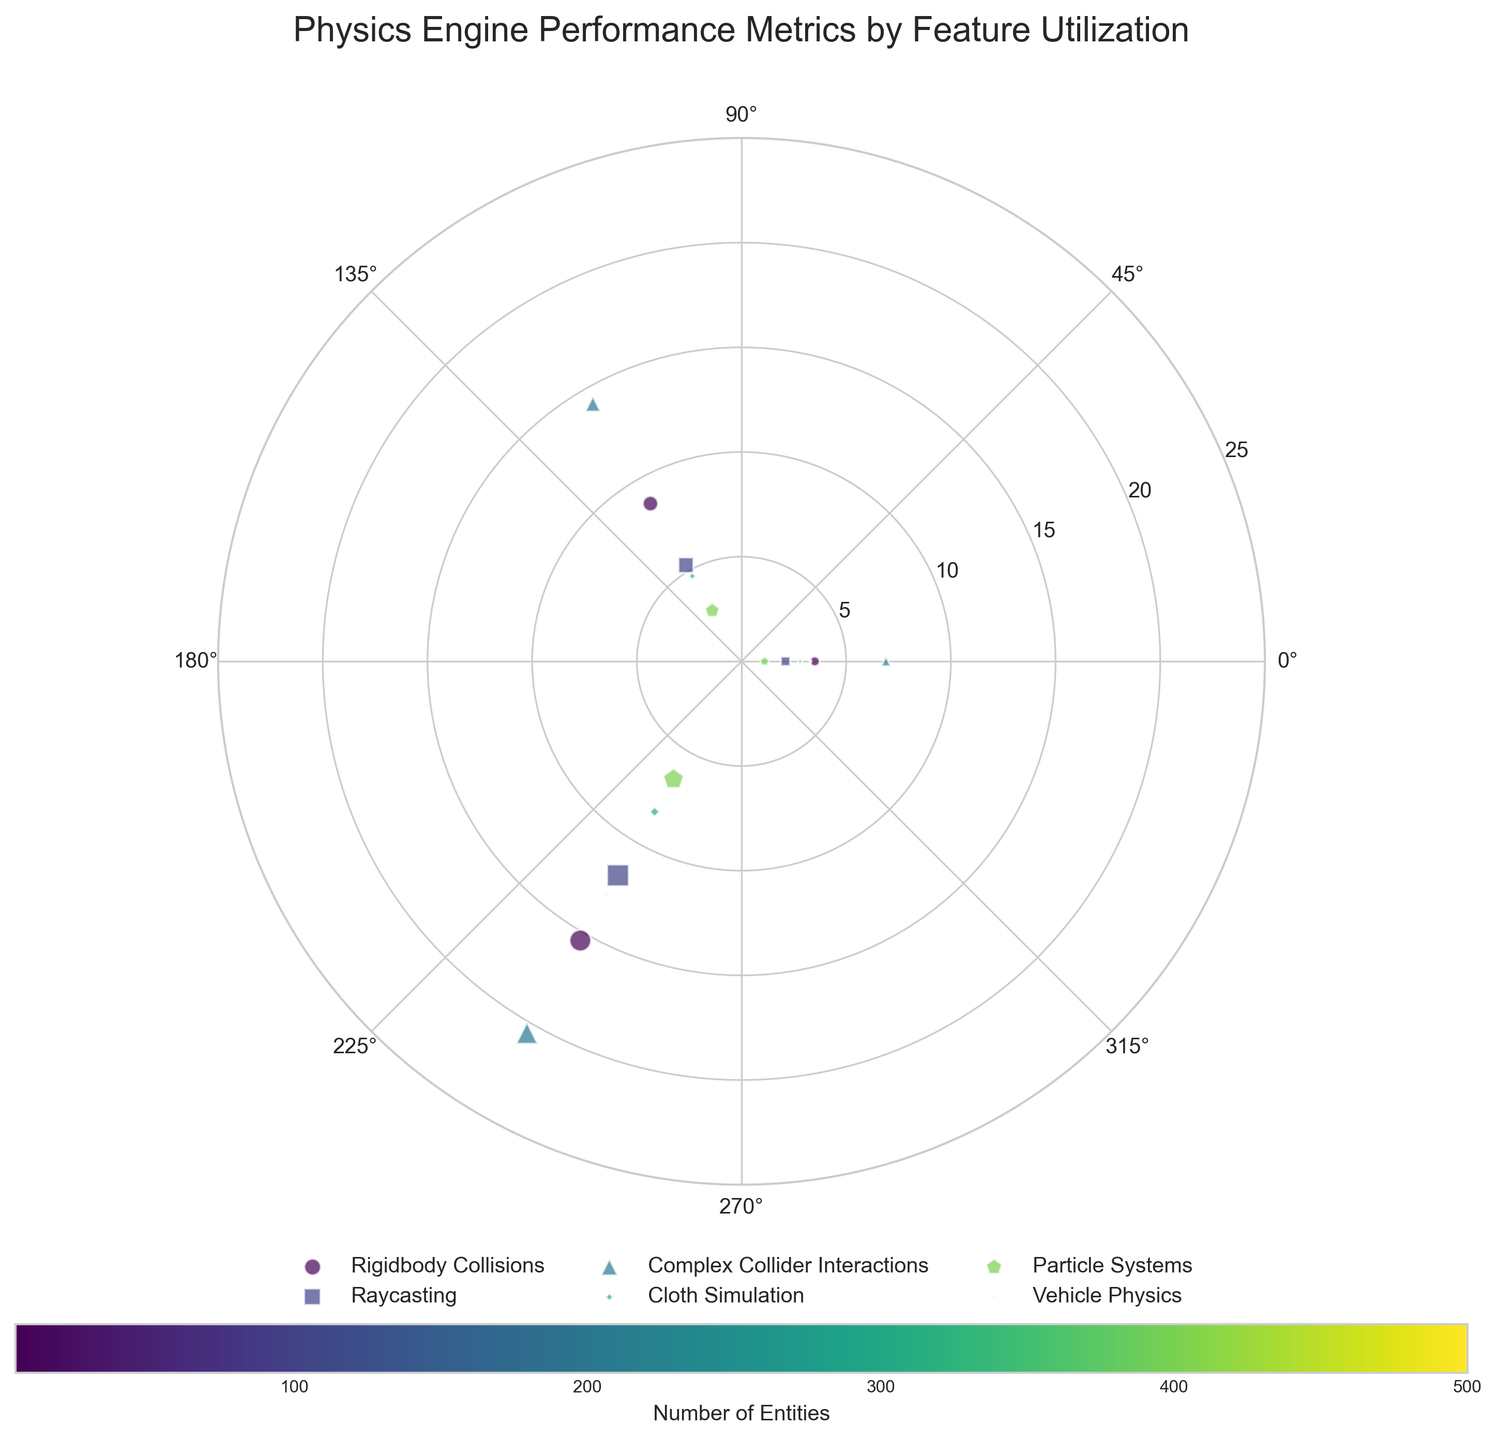What's the title of the figure? The title is typically located at the top of the figure. In this case, it reads "Physics Engine Performance Metrics by Feature Utilization".
Answer: Physics Engine Performance Metrics by Feature Utilization How many unique features are there in the plot? The figure legend shows different colored markers representing unique features. By counting these unique labels, we find there are 6 features: "Rigidbody Collisions", "Raycasting", "Complex Collider Interactions", "Cloth Simulation", "Particle Systems", and "Vehicle Physics".
Answer: 6 Which feature has the highest performance metric for the smallest entity count? Locate the smallest entity counts on the radial axis (innermost points), then check which has the highest radial distance (performance metric). For entities count of 5, "Vehicle Physics" has a performance metric of 3.3, which is the highest.
Answer: Vehicle Physics What's the average performance metric for "Raycasting" across all entity counts? Identify the performance metrics for "Raycasting" (2.1, 5.3, 11.8). Calculate the average: (2.1 + 5.3 + 11.8) / 3 = 6.4.
Answer: 6.4 Compare "Rigidbody Collisions" and "Cloth Simulation" features. Which one has a higher performance metric at the highest entity count? For "Rigidbody Collisions" at 500 entities, the performance metric is 15.4. For "Cloth Simulation" at 50 entities (which is the highest for this feature), the performance metric is 8.3. Compare these values: 15.4 > 8.3.
Answer: Rigidbody Collisions Which feature shows the highest performance metric regardless of entities count? Scan through all the radial distances for each feature. The highest value is 20.5 for "Complex Collider Interactions" when the entity count is 500.
Answer: Complex Collider Interactions For "Particle Systems", what is the difference in performance metric between 250 and 500 entities? Identify the performance metrics for 250 entities (2.8) and 500 entities (6.5). Compute the difference: 6.5 - 2.8 = 3.7.
Answer: 3.7 How are the entity counts visually represented in the plot? The size of the plotted points (markers) on the chart represents the entity counts. Larger sizes correspond to higher entity counts.
Answer: By marker size At 100 entities, which feature has the lowest performance metric? For 100 entities, compare the radial distances of all points: "Rigidbody Collisions" (3.5), "Raycasting" (2.1), "Complex Collider Interactions" (6.9), "Particle Systems" (1.1). The lowest performance metric is for "Particle Systems".
Answer: Particle Systems What is the range of performance metrics for "Complex Collider Interactions" across different entities? Identify all performance metrics for "Complex Collider Interactions" (6.9, 14.2, 20.5). The range is from minimum to maximum: 20.5 - 6.9 = 13.6.
Answer: 13.6 